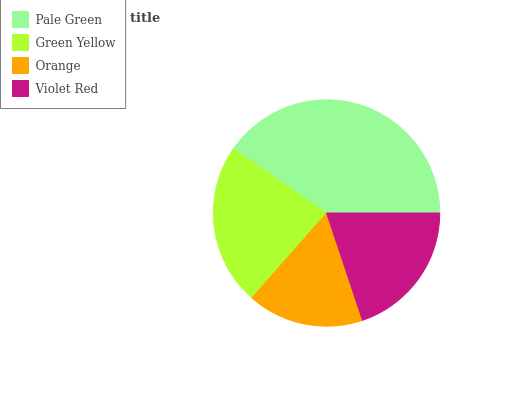Is Orange the minimum?
Answer yes or no. Yes. Is Pale Green the maximum?
Answer yes or no. Yes. Is Green Yellow the minimum?
Answer yes or no. No. Is Green Yellow the maximum?
Answer yes or no. No. Is Pale Green greater than Green Yellow?
Answer yes or no. Yes. Is Green Yellow less than Pale Green?
Answer yes or no. Yes. Is Green Yellow greater than Pale Green?
Answer yes or no. No. Is Pale Green less than Green Yellow?
Answer yes or no. No. Is Green Yellow the high median?
Answer yes or no. Yes. Is Violet Red the low median?
Answer yes or no. Yes. Is Orange the high median?
Answer yes or no. No. Is Pale Green the low median?
Answer yes or no. No. 